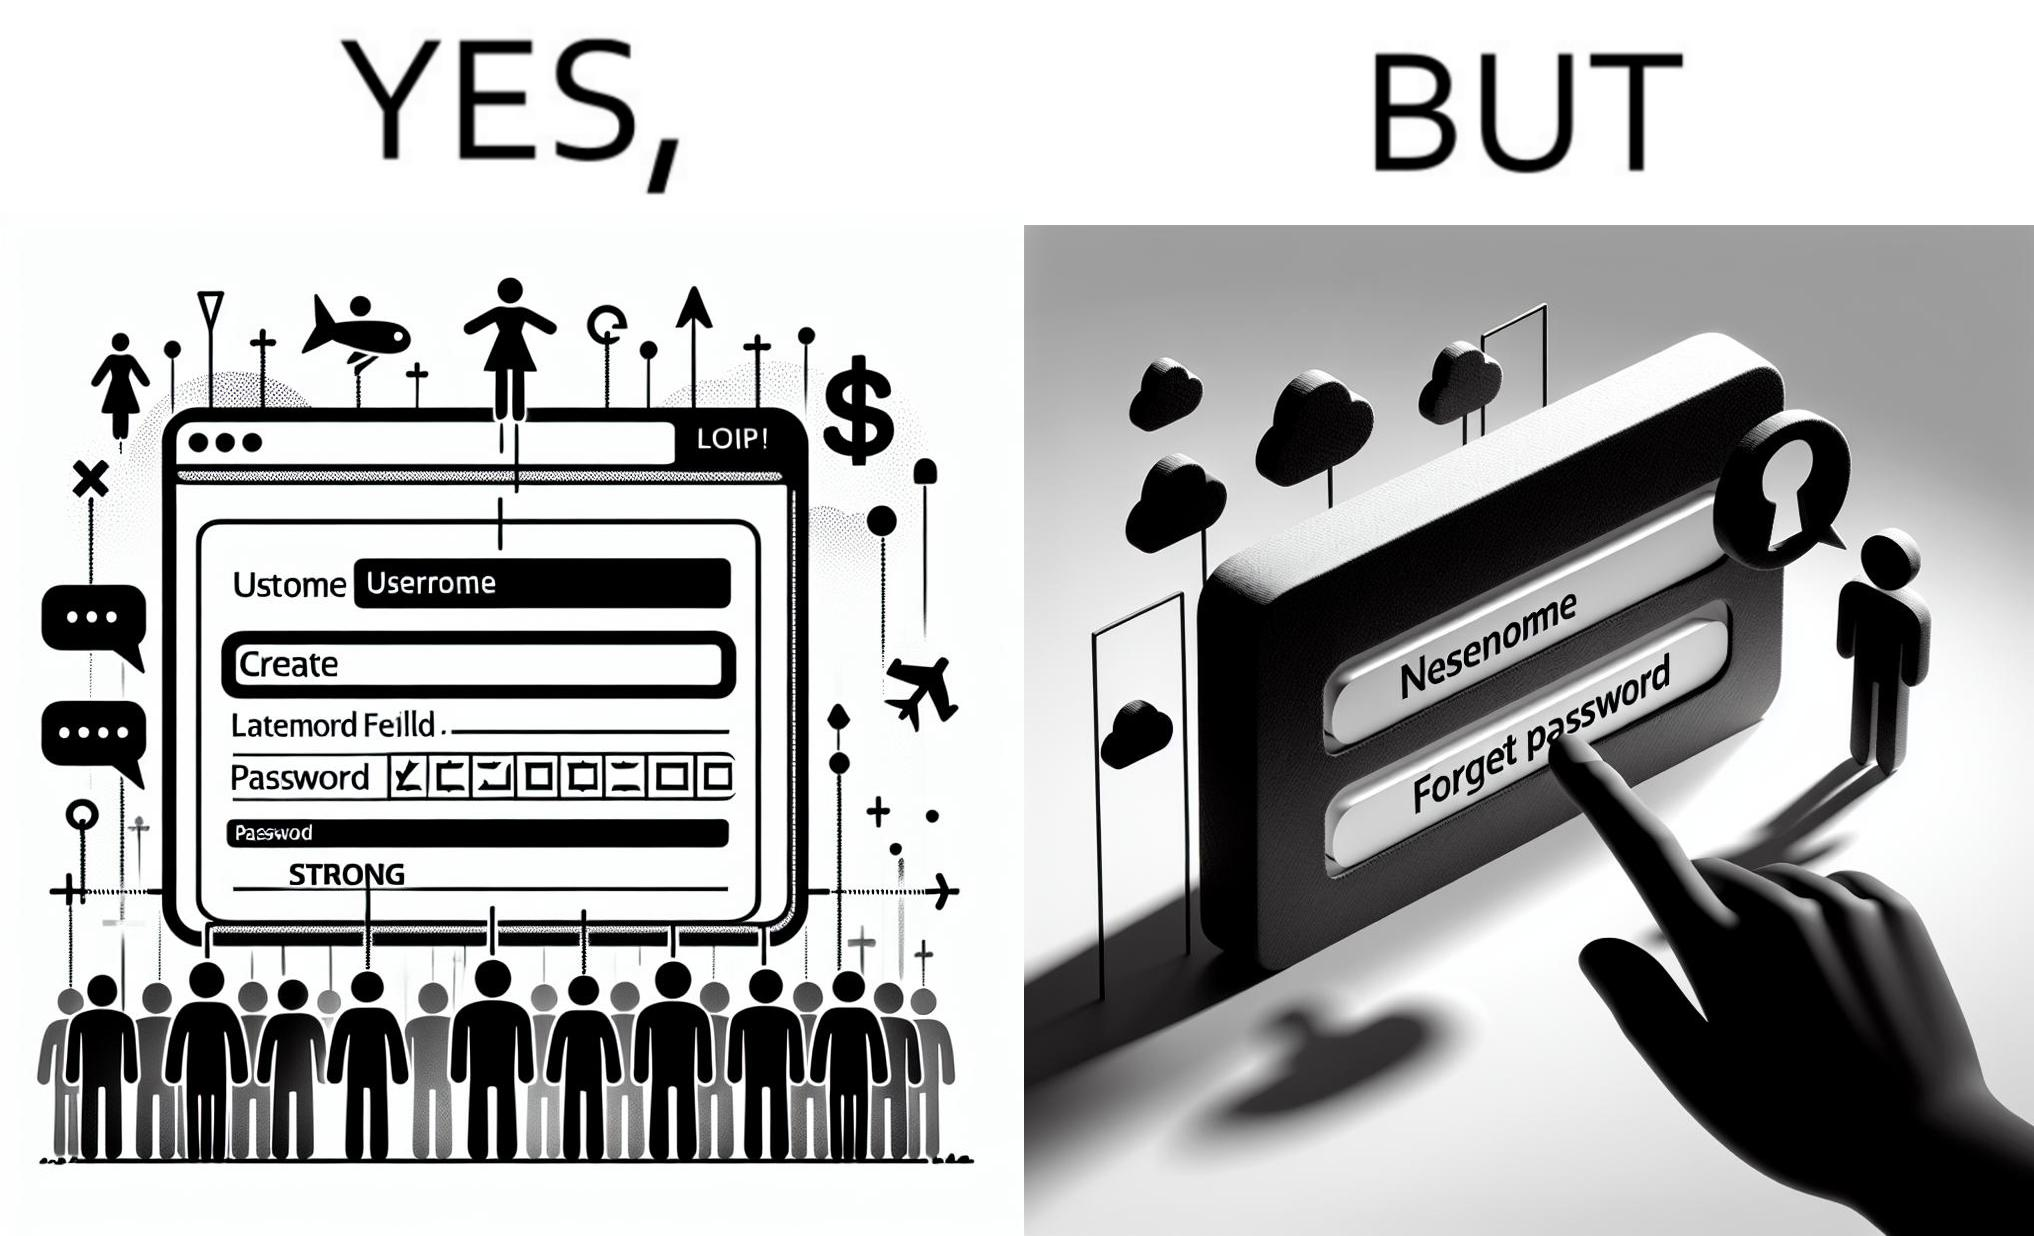Describe the content of this image. The image is ironic, because people set such a strong passwords for their accounts that they even forget the password and need to reset them 